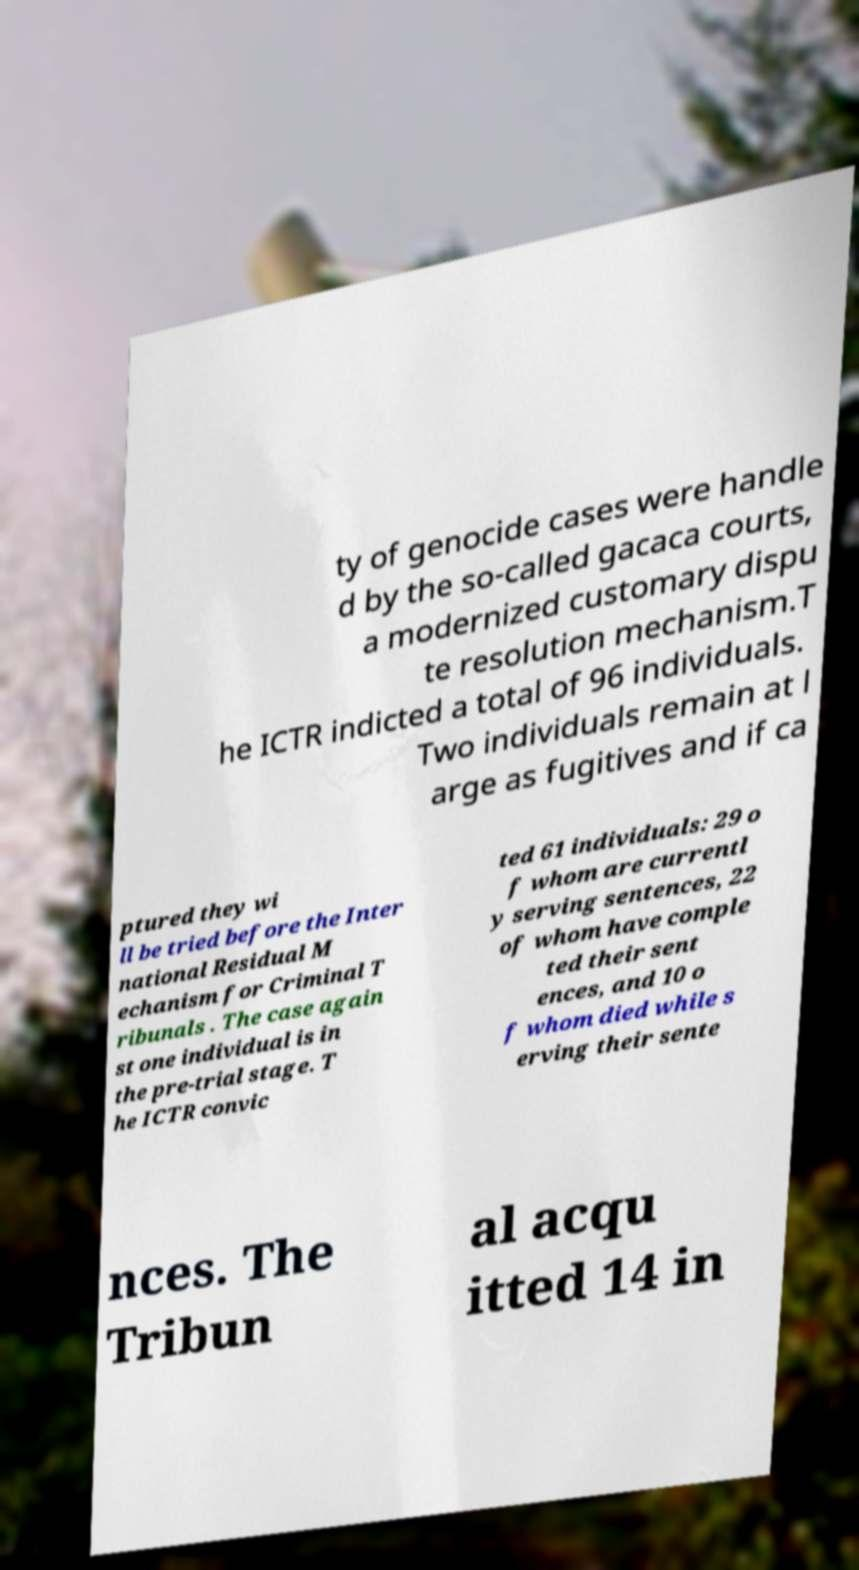Can you read and provide the text displayed in the image?This photo seems to have some interesting text. Can you extract and type it out for me? ty of genocide cases were handle d by the so-called gacaca courts, a modernized customary dispu te resolution mechanism.T he ICTR indicted a total of 96 individuals. Two individuals remain at l arge as fugitives and if ca ptured they wi ll be tried before the Inter national Residual M echanism for Criminal T ribunals . The case again st one individual is in the pre-trial stage. T he ICTR convic ted 61 individuals: 29 o f whom are currentl y serving sentences, 22 of whom have comple ted their sent ences, and 10 o f whom died while s erving their sente nces. The Tribun al acqu itted 14 in 